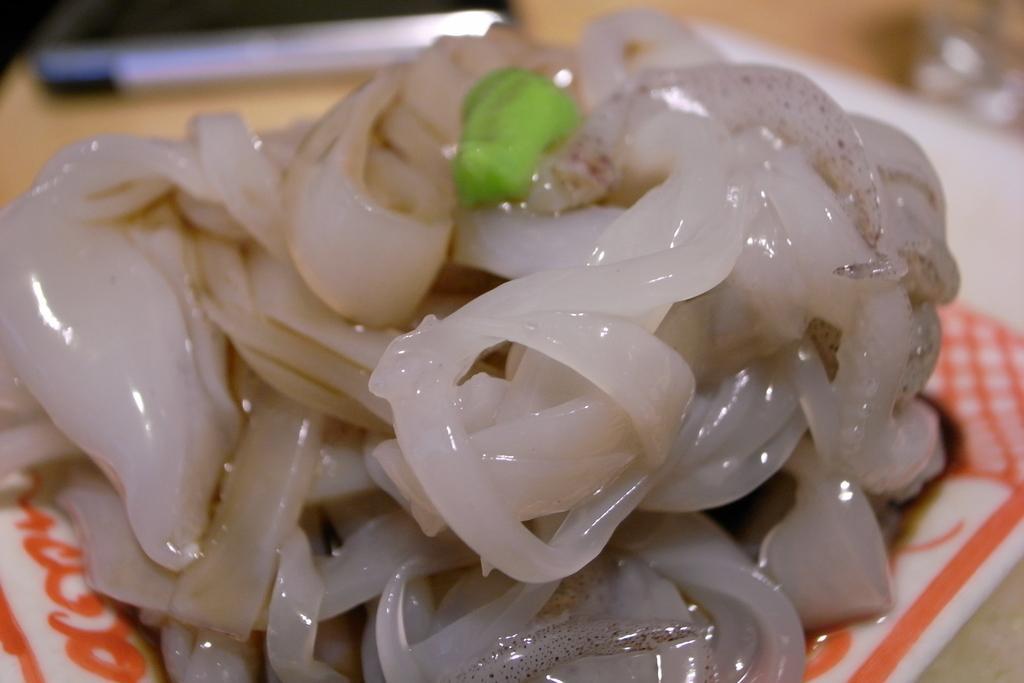Could you give a brief overview of what you see in this image? In this picture we can see some food present in the plate, there is a blurry background. 